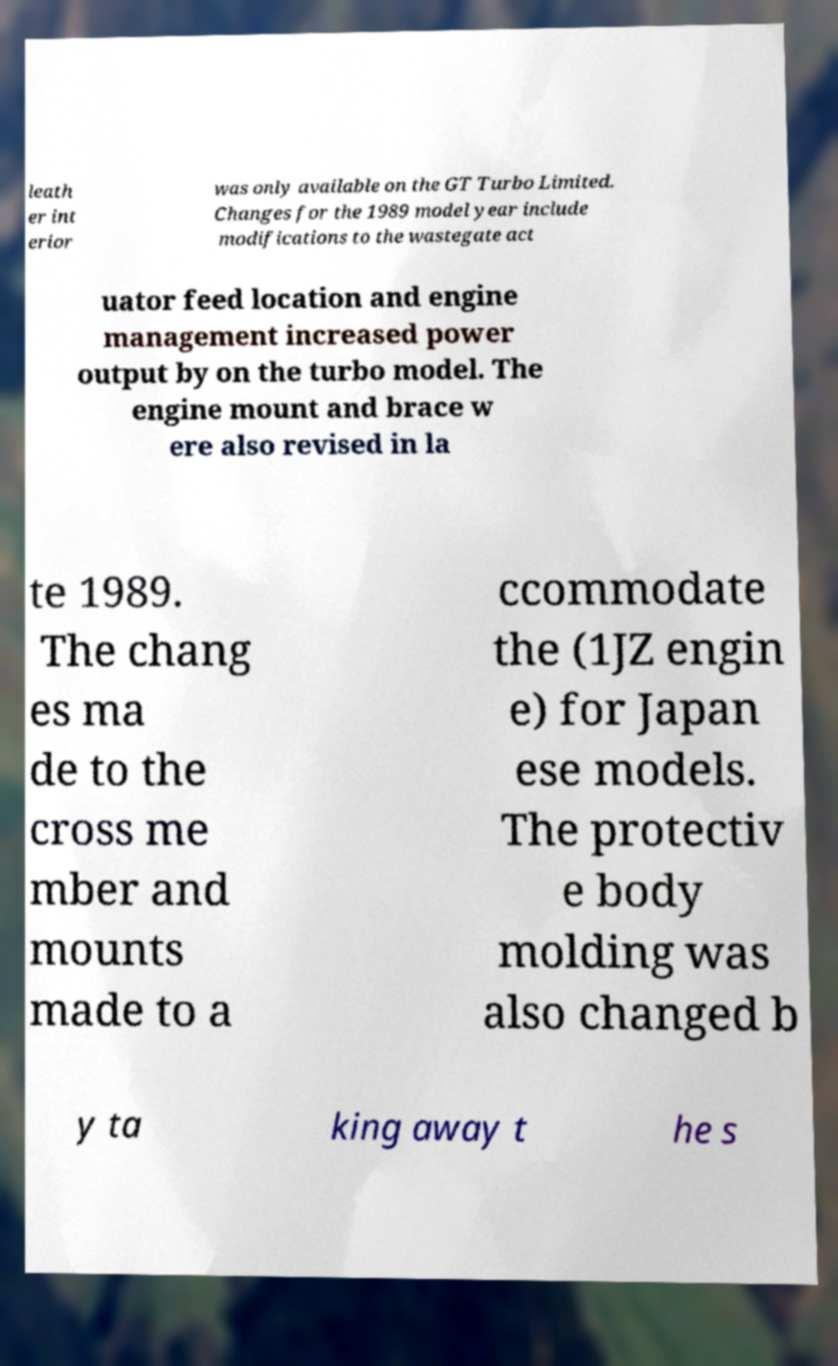Could you extract and type out the text from this image? leath er int erior was only available on the GT Turbo Limited. Changes for the 1989 model year include modifications to the wastegate act uator feed location and engine management increased power output by on the turbo model. The engine mount and brace w ere also revised in la te 1989. The chang es ma de to the cross me mber and mounts made to a ccommodate the (1JZ engin e) for Japan ese models. The protectiv e body molding was also changed b y ta king away t he s 